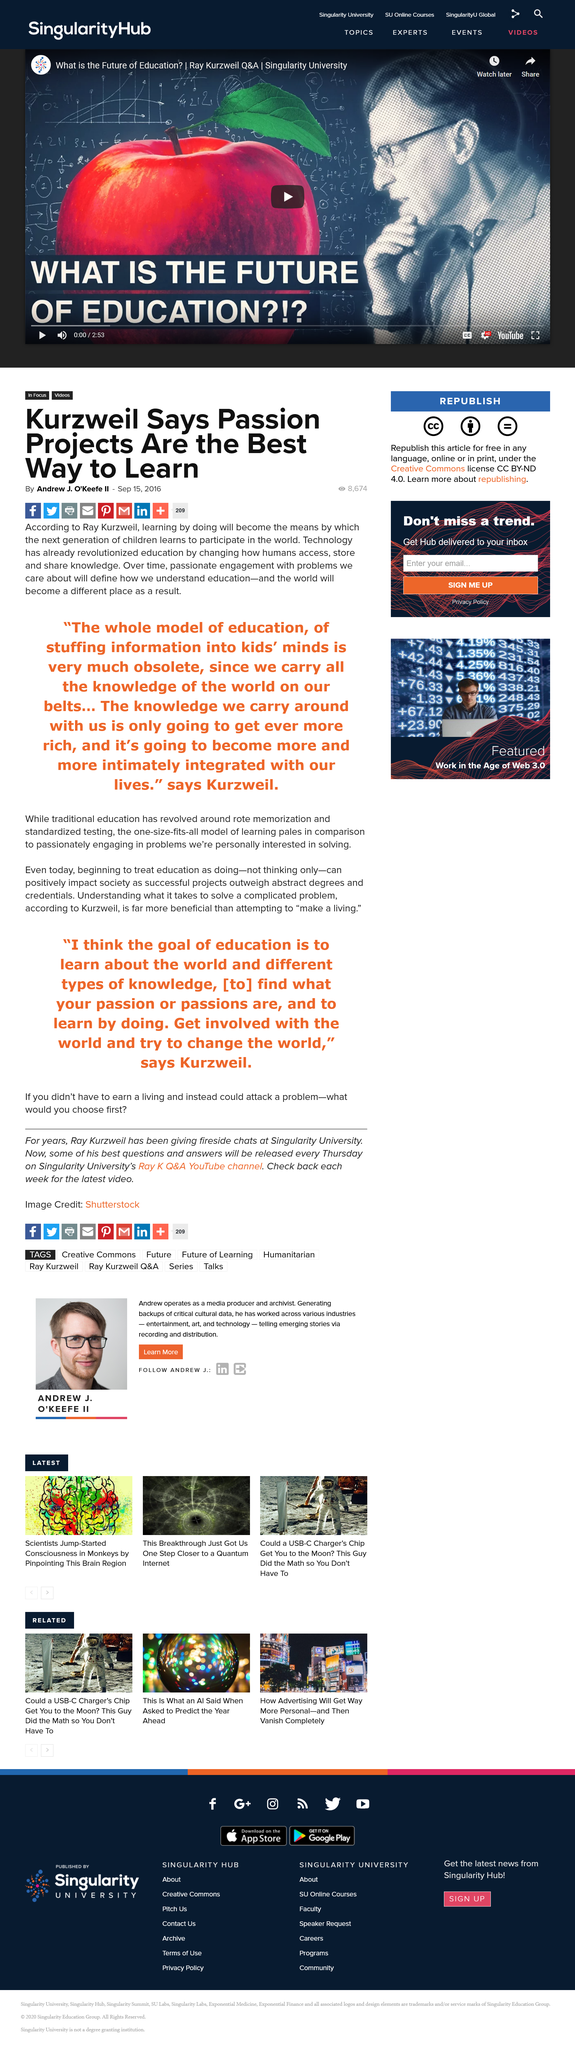Outline some significant characteristics in this image. The article is about the topic of learning in education. The article was written on September 15, 2016, as stated in the article. It is believed by Ray Kurzweil that learning by doing will be the means by which the next generation of children will learn to participate in the world. 